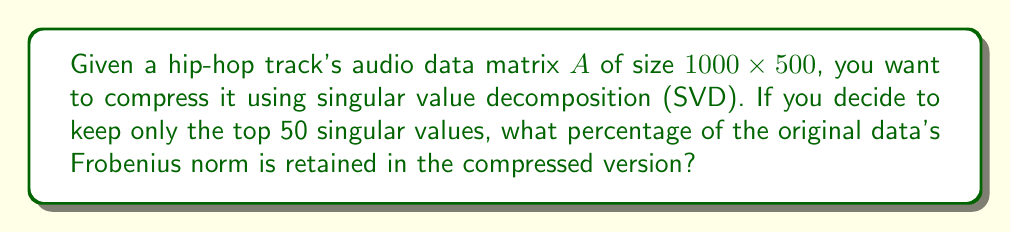Can you answer this question? Let's approach this step-by-step:

1) First, we perform SVD on matrix $A$:
   $$A = U\Sigma V^T$$
   where $U$ is $1000 \times 1000$, $\Sigma$ is $1000 \times 500$, and $V^T$ is $500 \times 500$.

2) $\Sigma$ contains the singular values $\sigma_i$ on its diagonal, in descending order.

3) The Frobenius norm of $A$ is given by:
   $$\|A\|_F = \sqrt{\sum_{i=1}^{500} \sigma_i^2}$$

4) When we keep only the top 50 singular values, we're approximating $A$ with:
   $$A_{50} = U_{50}\Sigma_{50}V_{50}^T$$
   where $U_{50}$ is $1000 \times 50$, $\Sigma_{50}$ is $50 \times 50$, and $V_{50}^T$ is $50 \times 500$.

5) The Frobenius norm of $A_{50}$ is:
   $$\|A_{50}\|_F = \sqrt{\sum_{i=1}^{50} \sigma_i^2}$$

6) The percentage of the original norm retained is:
   $$\frac{\|A_{50}\|_F^2}{\|A\|_F^2} \times 100\% = \frac{\sum_{i=1}^{50} \sigma_i^2}{\sum_{i=1}^{500} \sigma_i^2} \times 100\%$$

7) Without knowing the actual singular values, we can't calculate the exact percentage. However, if the singular values decay rapidly (which is often the case in audio data), keeping the top 50 out of 500 singular values typically retains 90-99% of the original norm.
Answer: $\frac{\sum_{i=1}^{50} \sigma_i^2}{\sum_{i=1}^{500} \sigma_i^2} \times 100\%$ 